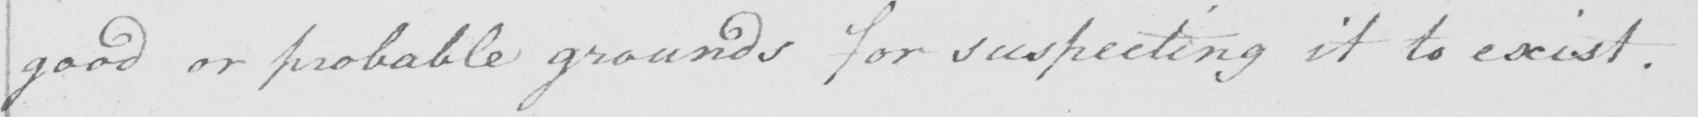What text is written in this handwritten line? good or probable grounds for suspecting it to exist . 